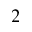Convert formula to latex. <formula><loc_0><loc_0><loc_500><loc_500>^ { 2 }</formula> 